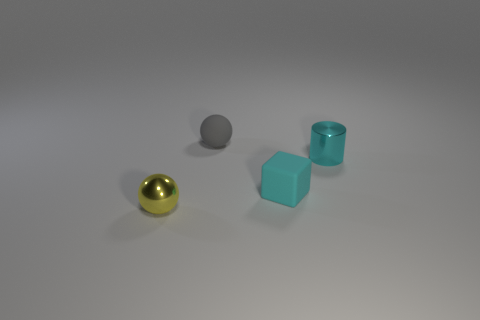What is the size of the metallic thing on the right side of the matte thing behind the small cyan metallic cylinder?
Offer a terse response. Small. What is the material of the other object that is the same shape as the yellow object?
Give a very brief answer. Rubber. What number of large yellow blocks are there?
Ensure brevity in your answer.  0. There is a sphere in front of the matte thing behind the matte thing on the right side of the small gray rubber sphere; what is its color?
Ensure brevity in your answer.  Yellow. Are there fewer yellow shiny balls than tiny matte things?
Offer a very short reply. Yes. There is a metal object that is the same shape as the small gray matte thing; what is its color?
Provide a succinct answer. Yellow. What color is the cylinder that is made of the same material as the yellow ball?
Your response must be concise. Cyan. What number of other matte things are the same size as the gray object?
Provide a short and direct response. 1. What is the gray object made of?
Ensure brevity in your answer.  Rubber. Are there more red rubber cylinders than metallic objects?
Your answer should be very brief. No. 